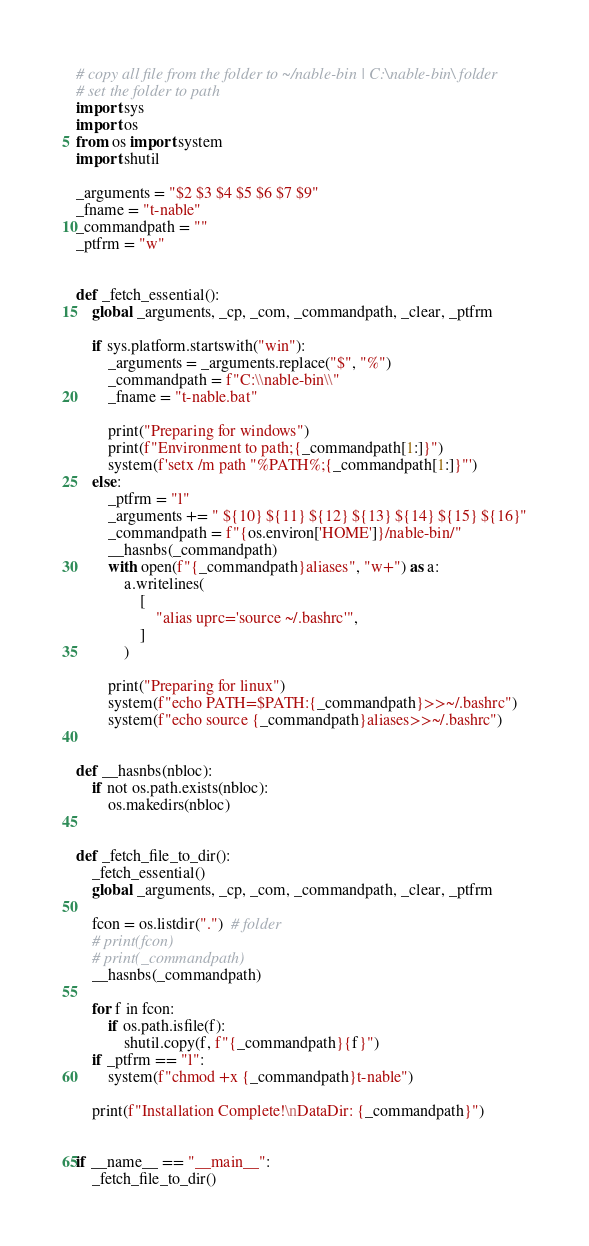<code> <loc_0><loc_0><loc_500><loc_500><_Python_># copy all file from the folder to ~/nable-bin | C:\nable-bin\ folder
# set the folder to path
import sys
import os
from os import system
import shutil

_arguments = "$2 $3 $4 $5 $6 $7 $9"
_fname = "t-nable"
_commandpath = ""
_ptfrm = "w"


def _fetch_essential():
    global _arguments, _cp, _com, _commandpath, _clear, _ptfrm

    if sys.platform.startswith("win"):
        _arguments = _arguments.replace("$", "%")
        _commandpath = f"C:\\nable-bin\\"
        _fname = "t-nable.bat"

        print("Preparing for windows")
        print(f"Environment to path;{_commandpath[1:]}")
        system(f'setx /m path "%PATH%;{_commandpath[1:]}"')
    else:
        _ptfrm = "l"
        _arguments += " ${10} ${11} ${12} ${13} ${14} ${15} ${16}"
        _commandpath = f"{os.environ['HOME']}/nable-bin/"
        __hasnbs(_commandpath)
        with open(f"{_commandpath}aliases", "w+") as a:
            a.writelines(
                [
                    "alias uprc='source ~/.bashrc'",
                ]
            )

        print("Preparing for linux")
        system(f"echo PATH=$PATH:{_commandpath}>>~/.bashrc")
        system(f"echo source {_commandpath}aliases>>~/.bashrc")


def __hasnbs(nbloc):
    if not os.path.exists(nbloc):
        os.makedirs(nbloc)


def _fetch_file_to_dir():
    _fetch_essential()
    global _arguments, _cp, _com, _commandpath, _clear, _ptfrm

    fcon = os.listdir(".")  # folder
    # print(fcon)
    # print(_commandpath)
    __hasnbs(_commandpath)

    for f in fcon:
        if os.path.isfile(f):
            shutil.copy(f, f"{_commandpath}{f}")
    if _ptfrm == "l":
        system(f"chmod +x {_commandpath}t-nable")

    print(f"Installation Complete!\nDataDir: {_commandpath}")


if __name__ == "__main__":
    _fetch_file_to_dir()</code> 